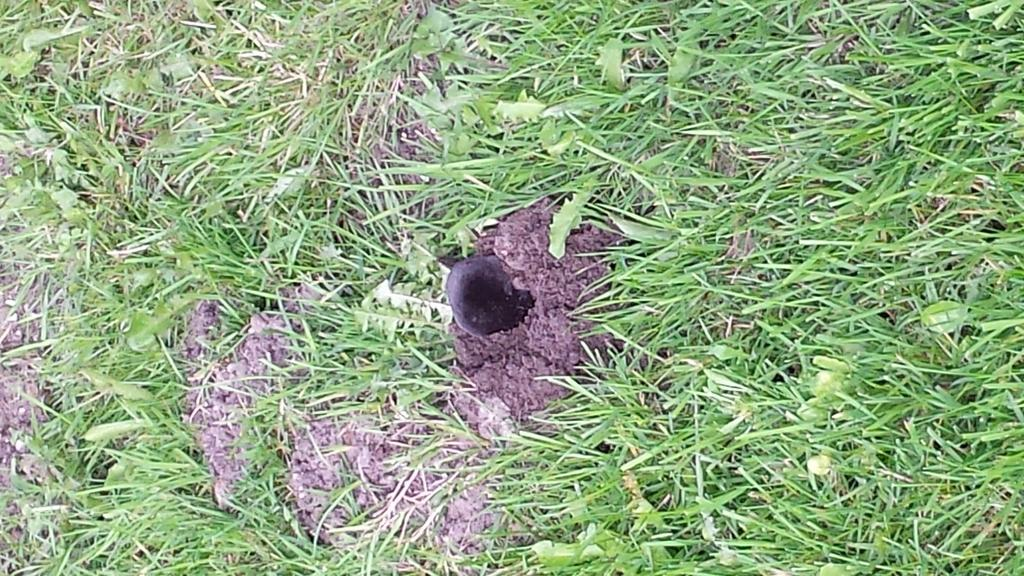What type of vegetation can be seen in the image? There is grass in the image. What else can be seen in the image besides grass? There are leaves in the image. Can you describe the black object in the image? There is a black object in the image, but its specific details are not clear from the provided facts. How does the grass spark in the image? There is no indication of a spark in the image; the grass is simply visible. 